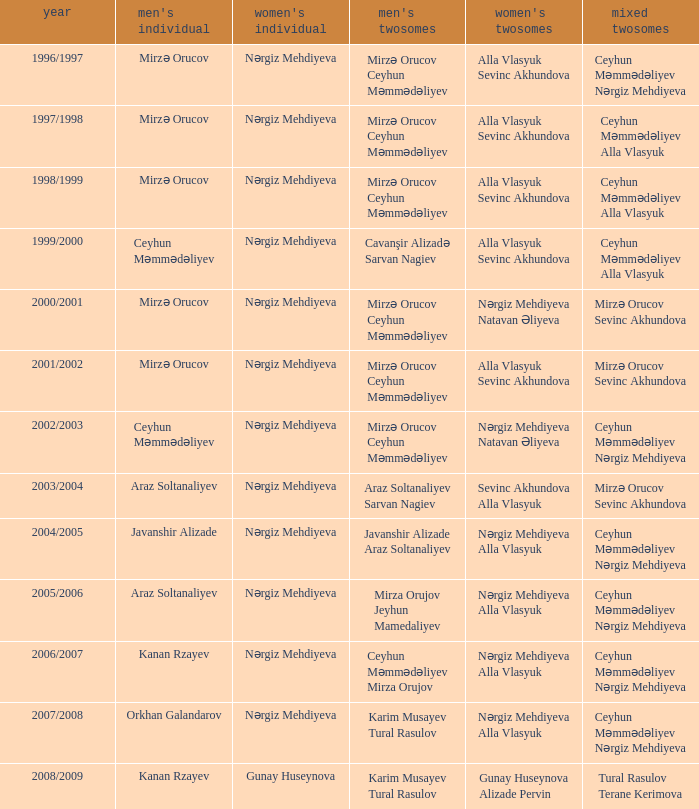Can you parse all the data within this table? {'header': ['year', "men's individual", "women's individual", "men's twosomes", "women's twosomes", 'mixed twosomes'], 'rows': [['1996/1997', 'Mirzə Orucov', 'Nərgiz Mehdiyeva', 'Mirzə Orucov Ceyhun Məmmədəliyev', 'Alla Vlasyuk Sevinc Akhundova', 'Ceyhun Məmmədəliyev Nərgiz Mehdiyeva'], ['1997/1998', 'Mirzə Orucov', 'Nərgiz Mehdiyeva', 'Mirzə Orucov Ceyhun Məmmədəliyev', 'Alla Vlasyuk Sevinc Akhundova', 'Ceyhun Məmmədəliyev Alla Vlasyuk'], ['1998/1999', 'Mirzə Orucov', 'Nərgiz Mehdiyeva', 'Mirzə Orucov Ceyhun Məmmədəliyev', 'Alla Vlasyuk Sevinc Akhundova', 'Ceyhun Məmmədəliyev Alla Vlasyuk'], ['1999/2000', 'Ceyhun Məmmədəliyev', 'Nərgiz Mehdiyeva', 'Cavanşir Alizadə Sarvan Nagiev', 'Alla Vlasyuk Sevinc Akhundova', 'Ceyhun Məmmədəliyev Alla Vlasyuk'], ['2000/2001', 'Mirzə Orucov', 'Nərgiz Mehdiyeva', 'Mirzə Orucov Ceyhun Məmmədəliyev', 'Nərgiz Mehdiyeva Natavan Əliyeva', 'Mirzə Orucov Sevinc Akhundova'], ['2001/2002', 'Mirzə Orucov', 'Nərgiz Mehdiyeva', 'Mirzə Orucov Ceyhun Məmmədəliyev', 'Alla Vlasyuk Sevinc Akhundova', 'Mirzə Orucov Sevinc Akhundova'], ['2002/2003', 'Ceyhun Məmmədəliyev', 'Nərgiz Mehdiyeva', 'Mirzə Orucov Ceyhun Məmmədəliyev', 'Nərgiz Mehdiyeva Natavan Əliyeva', 'Ceyhun Məmmədəliyev Nərgiz Mehdiyeva'], ['2003/2004', 'Araz Soltanaliyev', 'Nərgiz Mehdiyeva', 'Araz Soltanaliyev Sarvan Nagiev', 'Sevinc Akhundova Alla Vlasyuk', 'Mirzə Orucov Sevinc Akhundova'], ['2004/2005', 'Javanshir Alizade', 'Nərgiz Mehdiyeva', 'Javanshir Alizade Araz Soltanaliyev', 'Nərgiz Mehdiyeva Alla Vlasyuk', 'Ceyhun Məmmədəliyev Nərgiz Mehdiyeva'], ['2005/2006', 'Araz Soltanaliyev', 'Nərgiz Mehdiyeva', 'Mirza Orujov Jeyhun Mamedaliyev', 'Nərgiz Mehdiyeva Alla Vlasyuk', 'Ceyhun Məmmədəliyev Nərgiz Mehdiyeva'], ['2006/2007', 'Kanan Rzayev', 'Nərgiz Mehdiyeva', 'Ceyhun Məmmədəliyev Mirza Orujov', 'Nərgiz Mehdiyeva Alla Vlasyuk', 'Ceyhun Məmmədəliyev Nərgiz Mehdiyeva'], ['2007/2008', 'Orkhan Galandarov', 'Nərgiz Mehdiyeva', 'Karim Musayev Tural Rasulov', 'Nərgiz Mehdiyeva Alla Vlasyuk', 'Ceyhun Məmmədəliyev Nərgiz Mehdiyeva'], ['2008/2009', 'Kanan Rzayev', 'Gunay Huseynova', 'Karim Musayev Tural Rasulov', 'Gunay Huseynova Alizade Pervin', 'Tural Rasulov Terane Kerimova']]} Who are all the womens doubles for the year 2008/2009? Gunay Huseynova Alizade Pervin. 